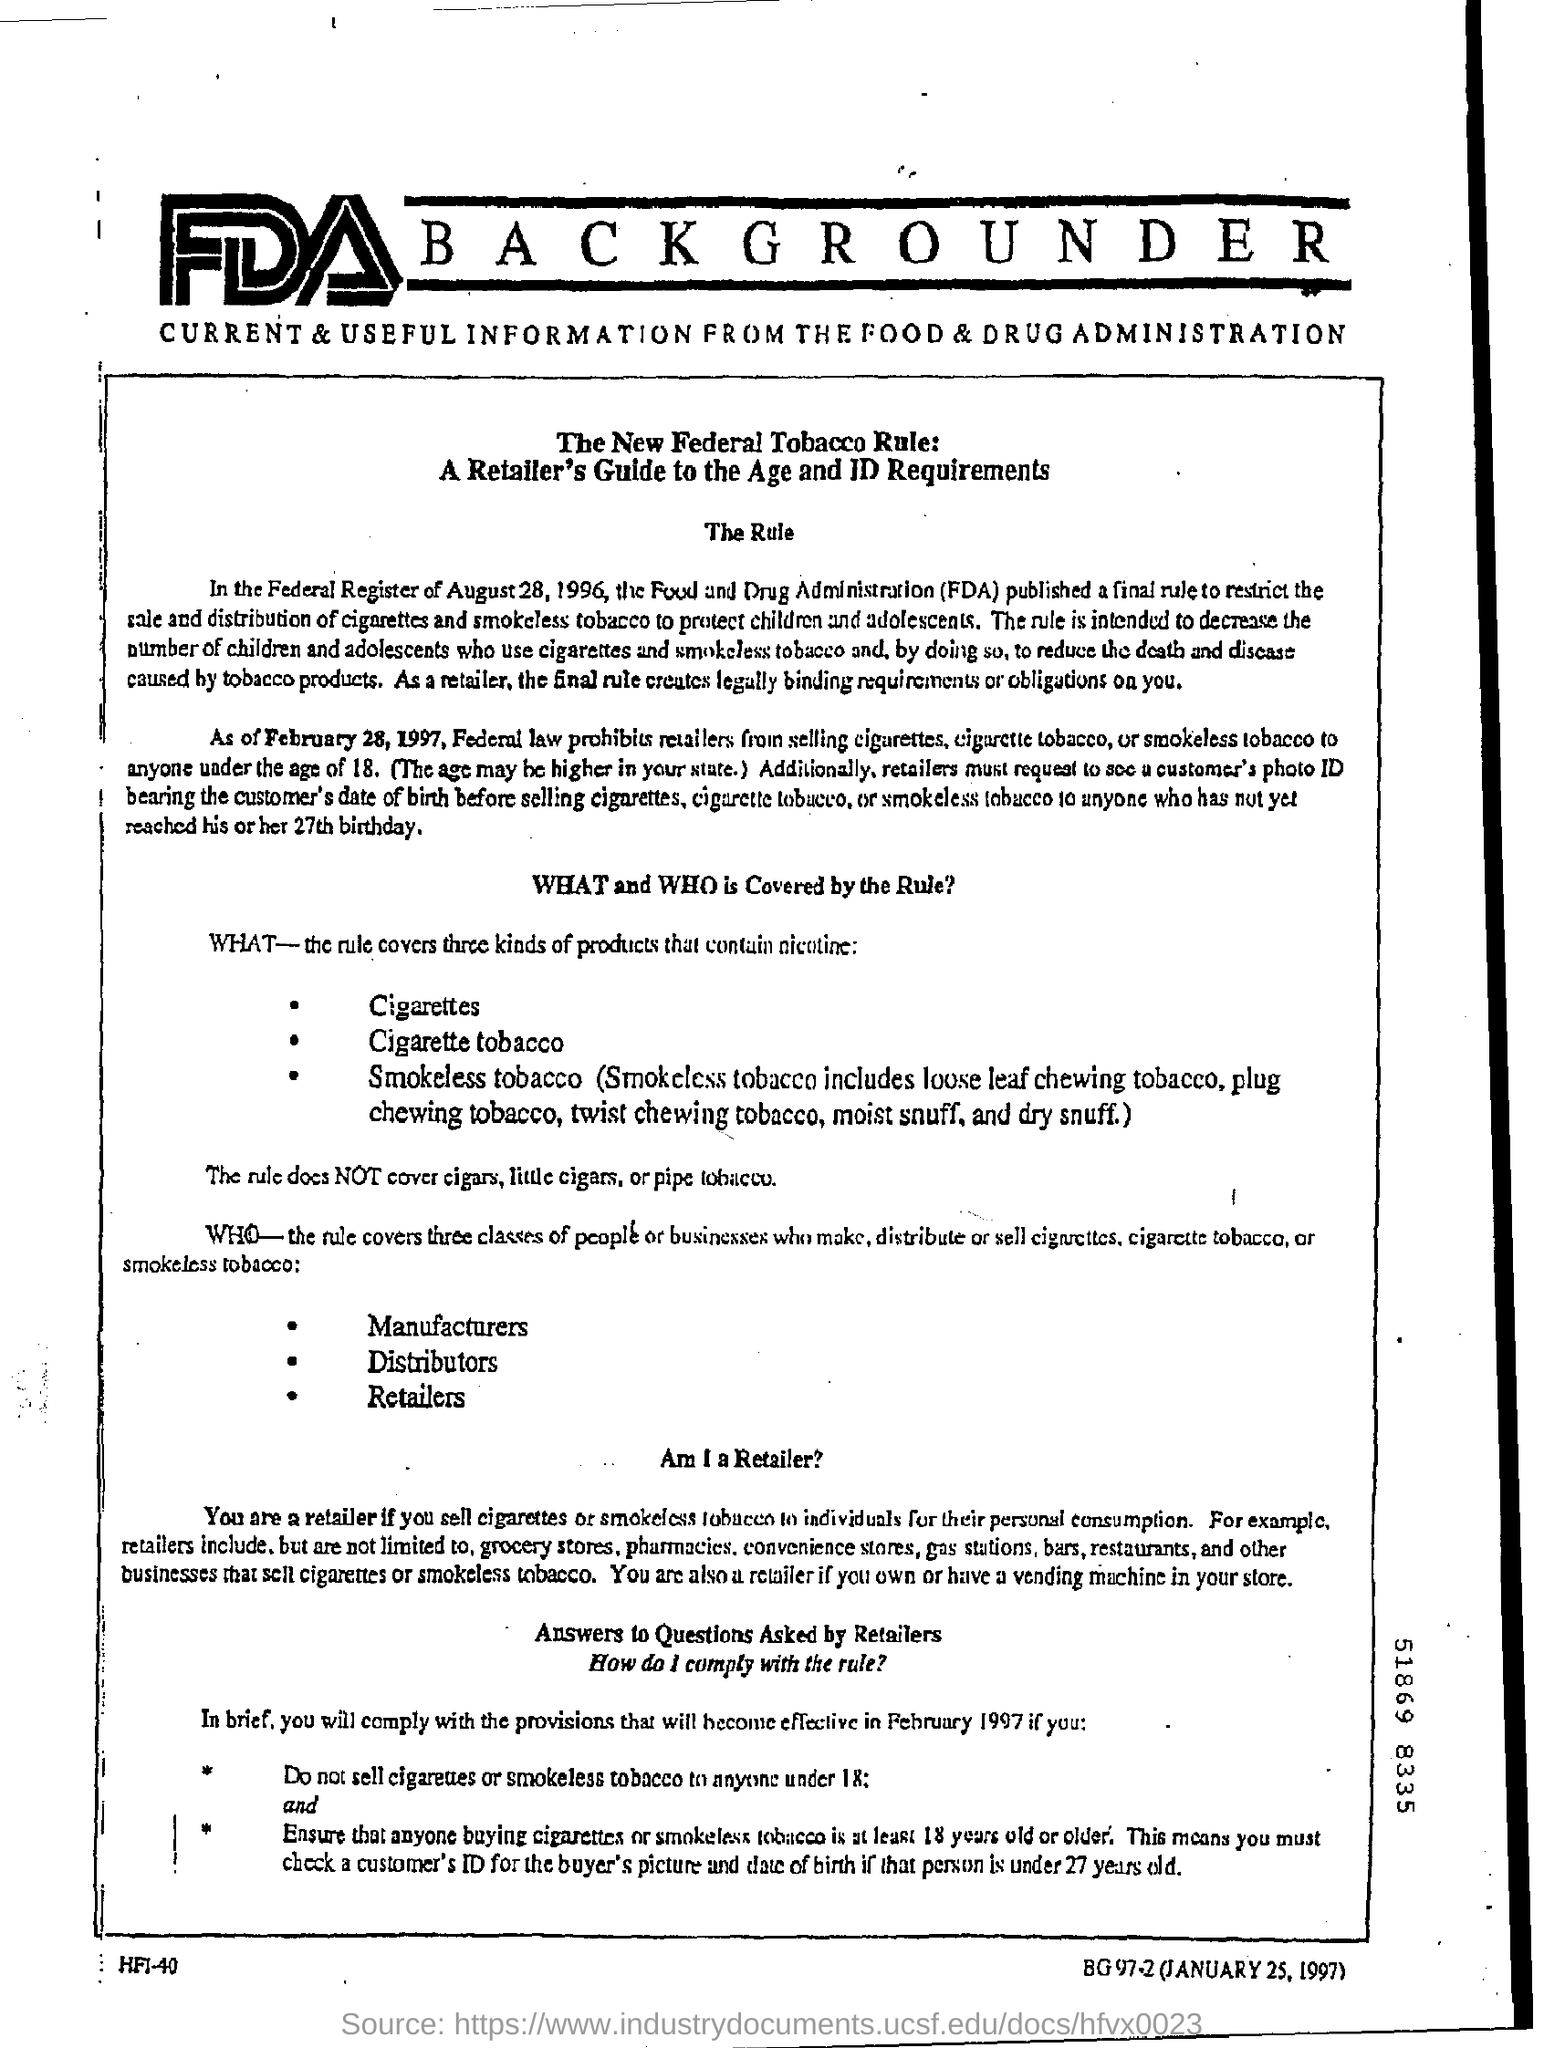Give some essential details in this illustration. Rule covers three types of products. Less than which age should cigarettes not be sold? 18 years old. The rule covers three types of products that contain nicotine. According to the document, a retailer is defined as someone who sells cigarettes or smokeless tobacco to individuals for their personal consumption. 